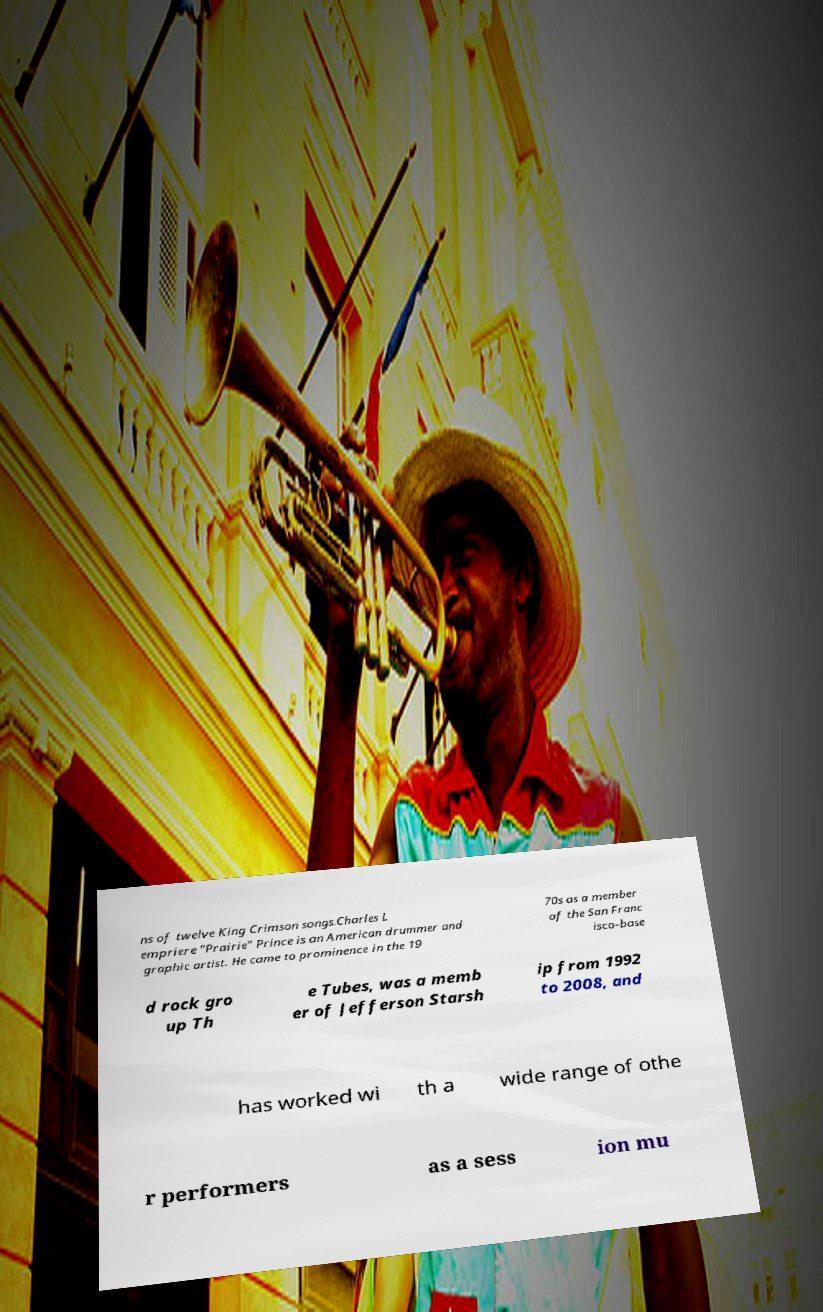What messages or text are displayed in this image? I need them in a readable, typed format. ns of twelve King Crimson songs.Charles L empriere "Prairie" Prince is an American drummer and graphic artist. He came to prominence in the 19 70s as a member of the San Franc isco–base d rock gro up Th e Tubes, was a memb er of Jefferson Starsh ip from 1992 to 2008, and has worked wi th a wide range of othe r performers as a sess ion mu 